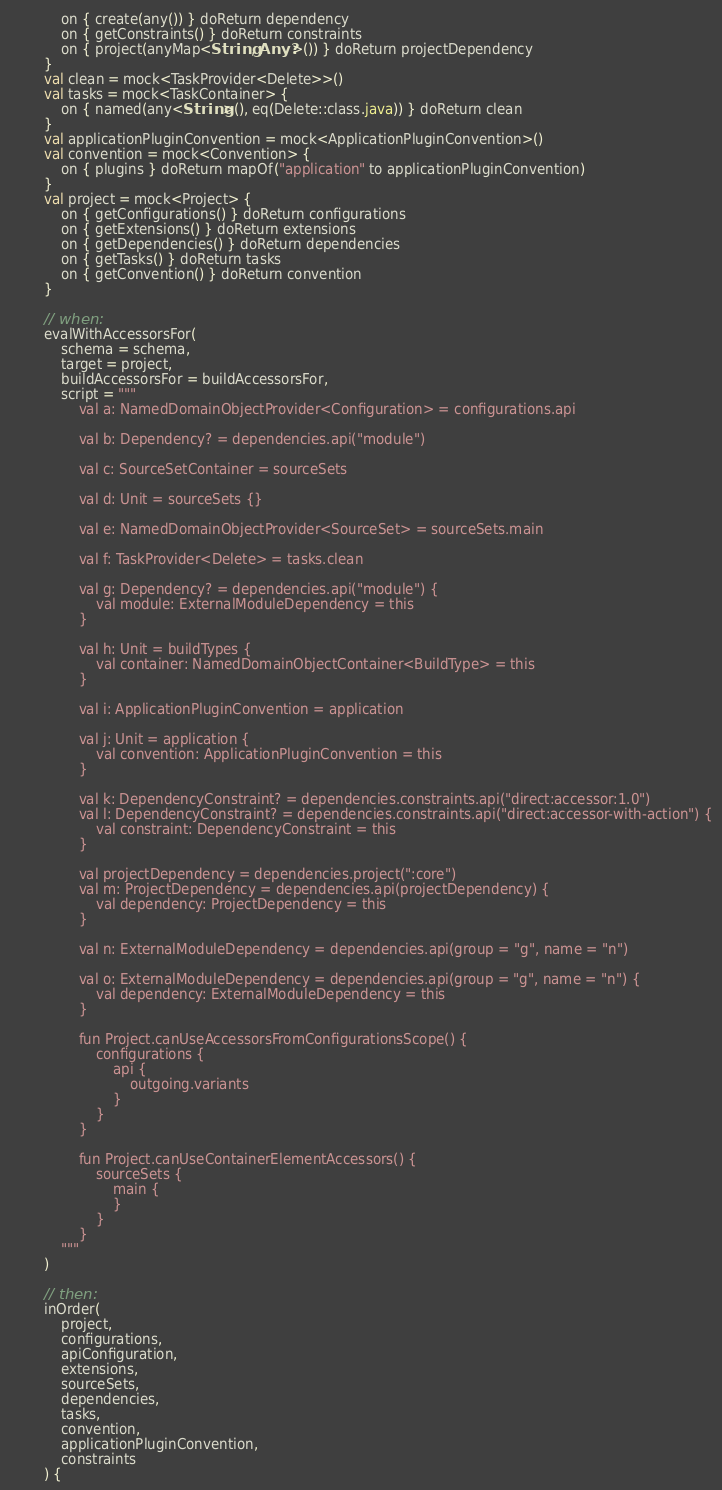Convert code to text. <code><loc_0><loc_0><loc_500><loc_500><_Kotlin_>            on { create(any()) } doReturn dependency
            on { getConstraints() } doReturn constraints
            on { project(anyMap<String, Any?>()) } doReturn projectDependency
        }
        val clean = mock<TaskProvider<Delete>>()
        val tasks = mock<TaskContainer> {
            on { named(any<String>(), eq(Delete::class.java)) } doReturn clean
        }
        val applicationPluginConvention = mock<ApplicationPluginConvention>()
        val convention = mock<Convention> {
            on { plugins } doReturn mapOf("application" to applicationPluginConvention)
        }
        val project = mock<Project> {
            on { getConfigurations() } doReturn configurations
            on { getExtensions() } doReturn extensions
            on { getDependencies() } doReturn dependencies
            on { getTasks() } doReturn tasks
            on { getConvention() } doReturn convention
        }

        // when:
        evalWithAccessorsFor(
            schema = schema,
            target = project,
            buildAccessorsFor = buildAccessorsFor,
            script = """
                val a: NamedDomainObjectProvider<Configuration> = configurations.api

                val b: Dependency? = dependencies.api("module")

                val c: SourceSetContainer = sourceSets

                val d: Unit = sourceSets {}

                val e: NamedDomainObjectProvider<SourceSet> = sourceSets.main

                val f: TaskProvider<Delete> = tasks.clean

                val g: Dependency? = dependencies.api("module") {
                    val module: ExternalModuleDependency = this
                }

                val h: Unit = buildTypes {
                    val container: NamedDomainObjectContainer<BuildType> = this
                }

                val i: ApplicationPluginConvention = application

                val j: Unit = application {
                    val convention: ApplicationPluginConvention = this
                }

                val k: DependencyConstraint? = dependencies.constraints.api("direct:accessor:1.0")
                val l: DependencyConstraint? = dependencies.constraints.api("direct:accessor-with-action") {
                    val constraint: DependencyConstraint = this
                }

                val projectDependency = dependencies.project(":core")
                val m: ProjectDependency = dependencies.api(projectDependency) {
                    val dependency: ProjectDependency = this
                }

                val n: ExternalModuleDependency = dependencies.api(group = "g", name = "n")

                val o: ExternalModuleDependency = dependencies.api(group = "g", name = "n") {
                    val dependency: ExternalModuleDependency = this
                }

                fun Project.canUseAccessorsFromConfigurationsScope() {
                    configurations {
                        api {
                            outgoing.variants
                        }
                    }
                }

                fun Project.canUseContainerElementAccessors() {
                    sourceSets {
                        main {
                        }
                    }
                }
            """
        )

        // then:
        inOrder(
            project,
            configurations,
            apiConfiguration,
            extensions,
            sourceSets,
            dependencies,
            tasks,
            convention,
            applicationPluginConvention,
            constraints
        ) {</code> 